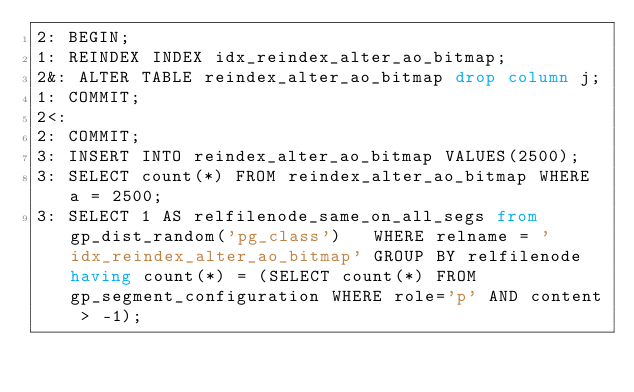Convert code to text. <code><loc_0><loc_0><loc_500><loc_500><_SQL_>2: BEGIN;
1: REINDEX INDEX idx_reindex_alter_ao_bitmap;
2&: ALTER TABLE reindex_alter_ao_bitmap drop column j;
1: COMMIT;
2<:
2: COMMIT;
3: INSERT INTO reindex_alter_ao_bitmap VALUES(2500);
3: SELECT count(*) FROM reindex_alter_ao_bitmap WHERE a = 2500;
3: SELECT 1 AS relfilenode_same_on_all_segs from gp_dist_random('pg_class')   WHERE relname = 'idx_reindex_alter_ao_bitmap' GROUP BY relfilenode having count(*) = (SELECT count(*) FROM gp_segment_configuration WHERE role='p' AND content > -1);
</code> 